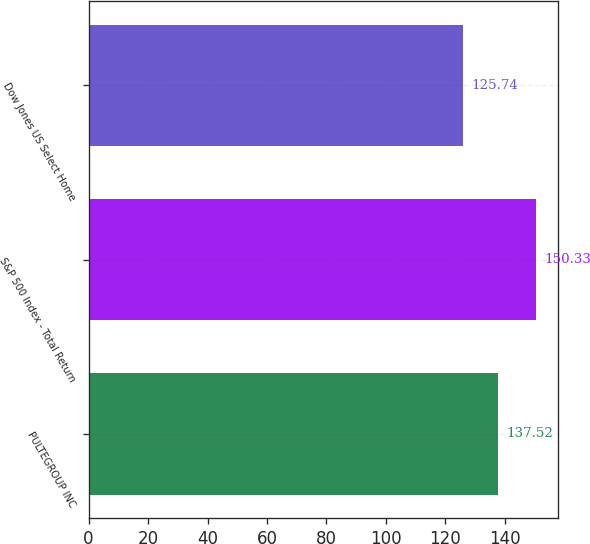<chart> <loc_0><loc_0><loc_500><loc_500><bar_chart><fcel>PULTEGROUP INC<fcel>S&P 500 Index - Total Return<fcel>Dow Jones US Select Home<nl><fcel>137.52<fcel>150.33<fcel>125.74<nl></chart> 